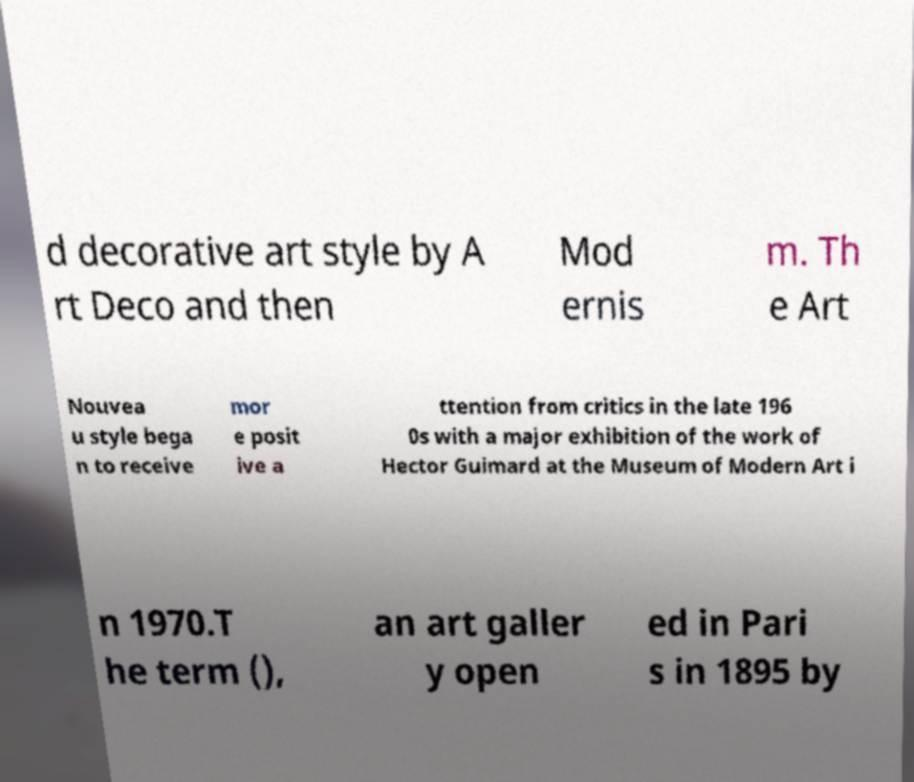Please identify and transcribe the text found in this image. d decorative art style by A rt Deco and then Mod ernis m. Th e Art Nouvea u style bega n to receive mor e posit ive a ttention from critics in the late 196 0s with a major exhibition of the work of Hector Guimard at the Museum of Modern Art i n 1970.T he term (), an art galler y open ed in Pari s in 1895 by 